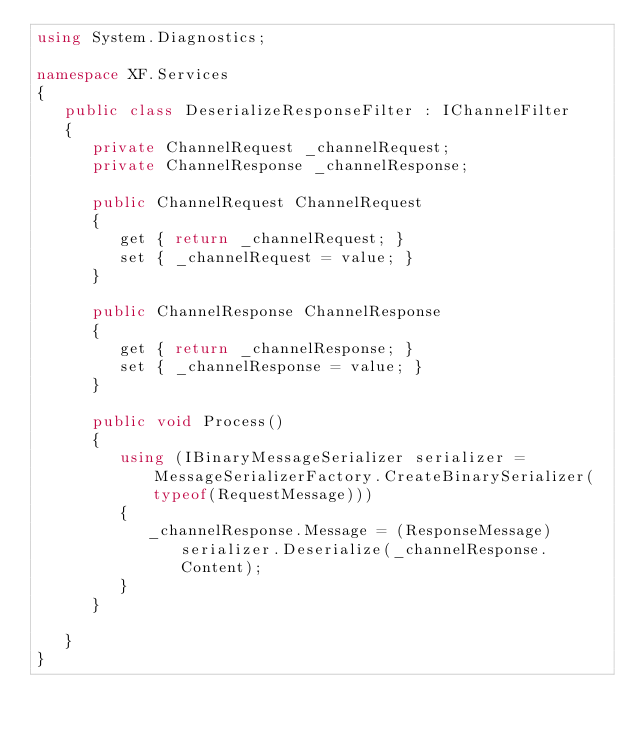Convert code to text. <code><loc_0><loc_0><loc_500><loc_500><_C#_>using System.Diagnostics;

namespace XF.Services
{
   public class DeserializeResponseFilter : IChannelFilter
   {
      private ChannelRequest _channelRequest;
      private ChannelResponse _channelResponse;

      public ChannelRequest ChannelRequest
      {
         get { return _channelRequest; }
         set { _channelRequest = value; }
      }

      public ChannelResponse ChannelResponse
      {
         get { return _channelResponse; }
         set { _channelResponse = value; }
      }

      public void Process()
      {
         using (IBinaryMessageSerializer serializer = MessageSerializerFactory.CreateBinarySerializer(typeof(RequestMessage)))
         {
            _channelResponse.Message = (ResponseMessage)serializer.Deserialize(_channelResponse.Content);
         }
      }

   }
}</code> 